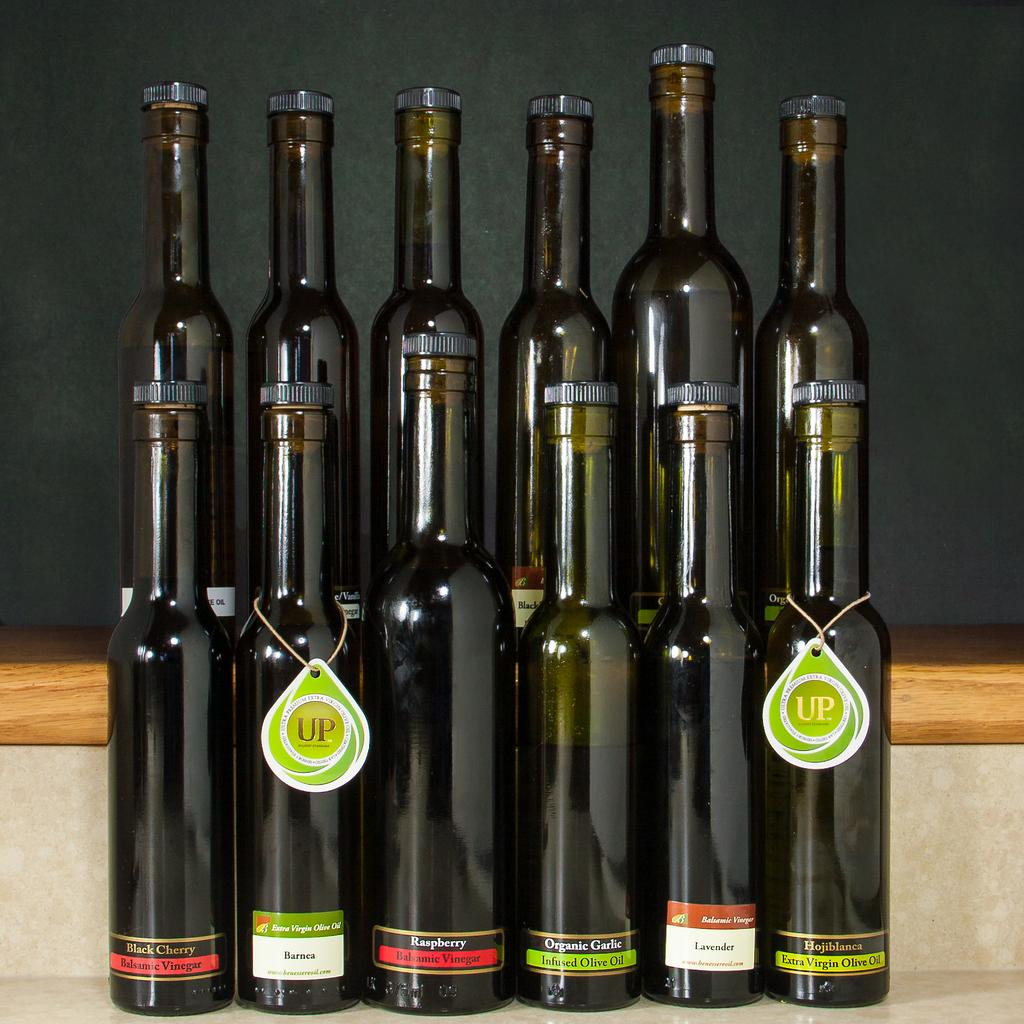Provide a one-sentence caption for the provided image. A group of tall brown bottles with some of them bearing a tag that reads "Up". 